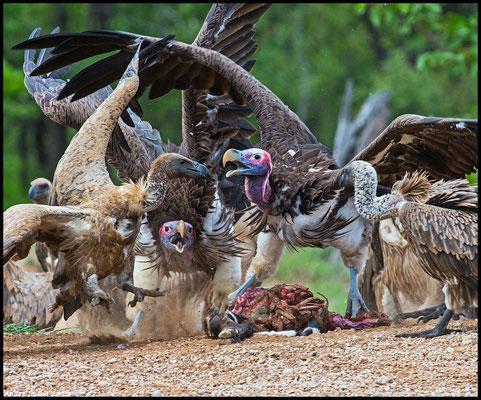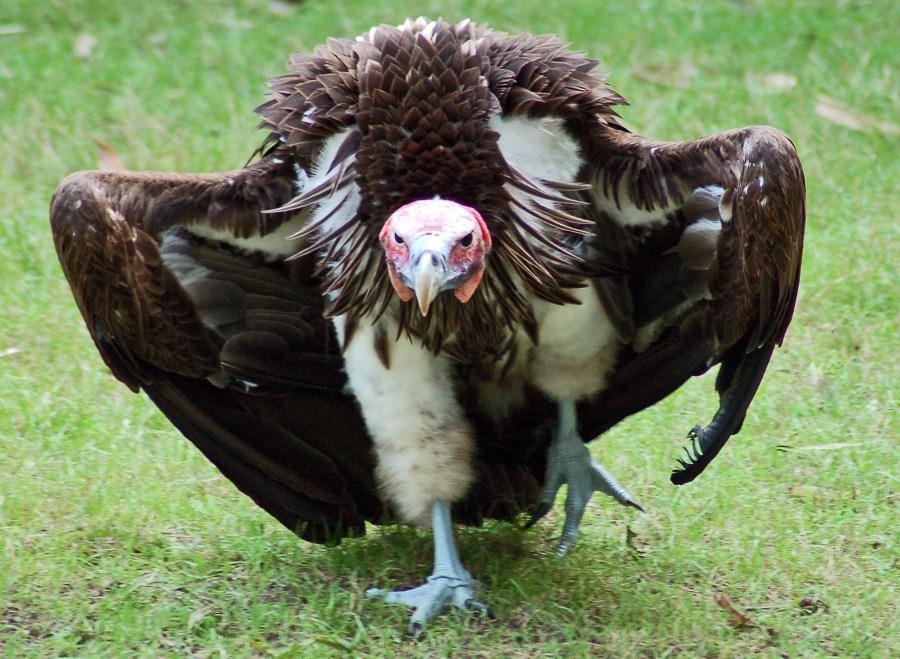The first image is the image on the left, the second image is the image on the right. Examine the images to the left and right. Is the description "One image in the pair includes vultures with a carcass." accurate? Answer yes or no. Yes. The first image is the image on the left, the second image is the image on the right. Examine the images to the left and right. Is the description "Right image shows a bird in the foreground with wings spread and off the ground." accurate? Answer yes or no. No. 